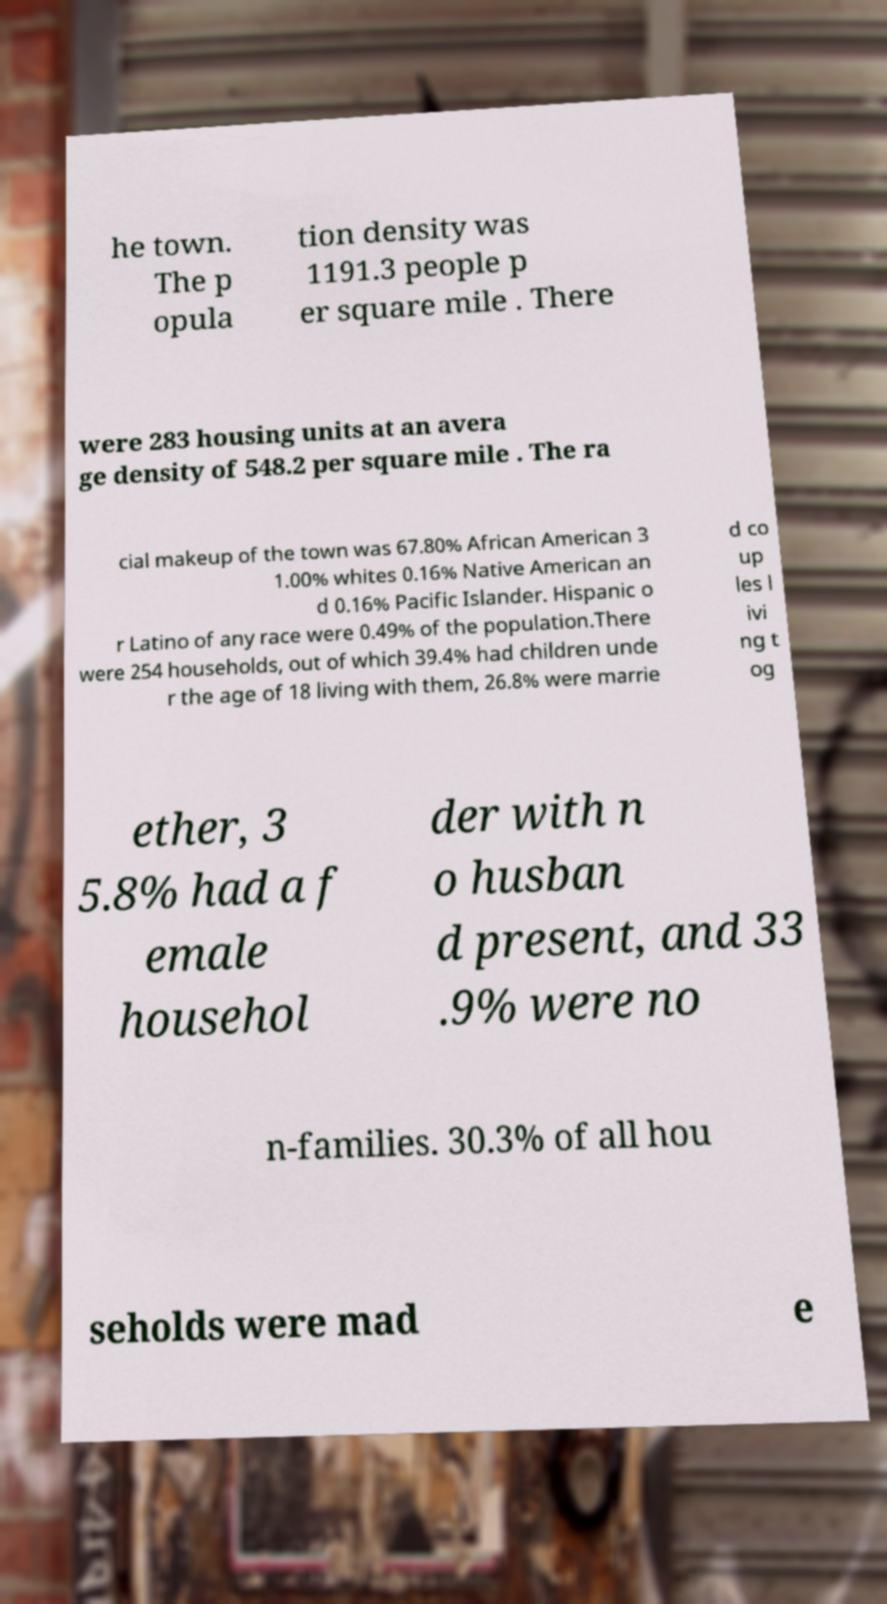Can you accurately transcribe the text from the provided image for me? he town. The p opula tion density was 1191.3 people p er square mile . There were 283 housing units at an avera ge density of 548.2 per square mile . The ra cial makeup of the town was 67.80% African American 3 1.00% whites 0.16% Native American an d 0.16% Pacific Islander. Hispanic o r Latino of any race were 0.49% of the population.There were 254 households, out of which 39.4% had children unde r the age of 18 living with them, 26.8% were marrie d co up les l ivi ng t og ether, 3 5.8% had a f emale househol der with n o husban d present, and 33 .9% were no n-families. 30.3% of all hou seholds were mad e 